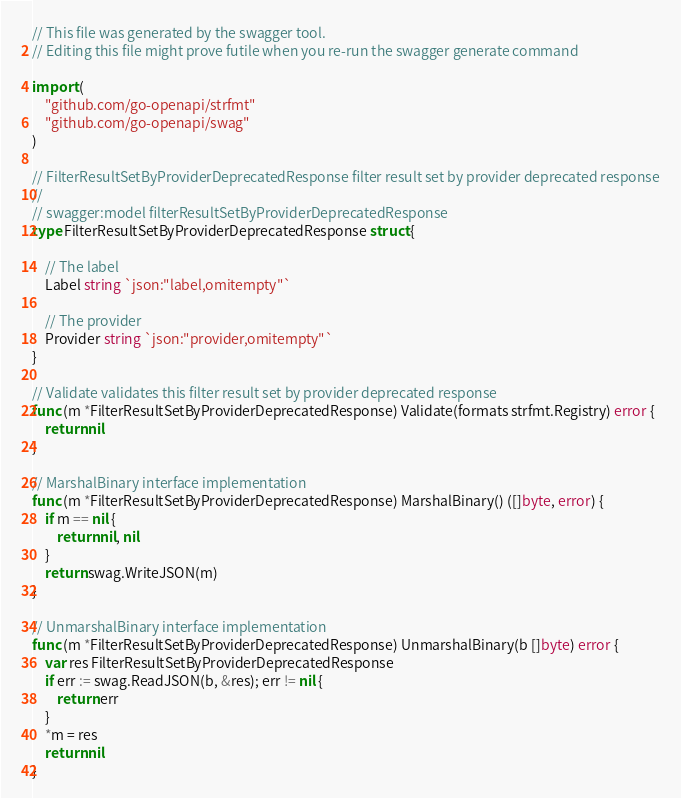Convert code to text. <code><loc_0><loc_0><loc_500><loc_500><_Go_>// This file was generated by the swagger tool.
// Editing this file might prove futile when you re-run the swagger generate command

import (
	"github.com/go-openapi/strfmt"
	"github.com/go-openapi/swag"
)

// FilterResultSetByProviderDeprecatedResponse filter result set by provider deprecated response
//
// swagger:model filterResultSetByProviderDeprecatedResponse
type FilterResultSetByProviderDeprecatedResponse struct {

	// The label
	Label string `json:"label,omitempty"`

	// The provider
	Provider string `json:"provider,omitempty"`
}

// Validate validates this filter result set by provider deprecated response
func (m *FilterResultSetByProviderDeprecatedResponse) Validate(formats strfmt.Registry) error {
	return nil
}

// MarshalBinary interface implementation
func (m *FilterResultSetByProviderDeprecatedResponse) MarshalBinary() ([]byte, error) {
	if m == nil {
		return nil, nil
	}
	return swag.WriteJSON(m)
}

// UnmarshalBinary interface implementation
func (m *FilterResultSetByProviderDeprecatedResponse) UnmarshalBinary(b []byte) error {
	var res FilterResultSetByProviderDeprecatedResponse
	if err := swag.ReadJSON(b, &res); err != nil {
		return err
	}
	*m = res
	return nil
}
</code> 